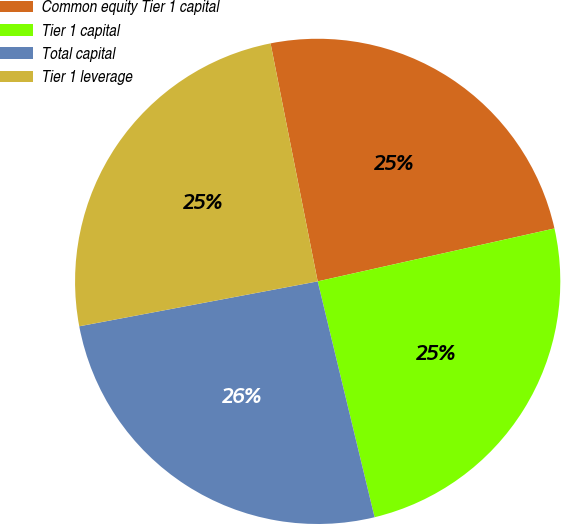Convert chart to OTSL. <chart><loc_0><loc_0><loc_500><loc_500><pie_chart><fcel>Common equity Tier 1 capital<fcel>Tier 1 capital<fcel>Total capital<fcel>Tier 1 leverage<nl><fcel>24.61%<fcel>24.73%<fcel>25.8%<fcel>24.85%<nl></chart> 